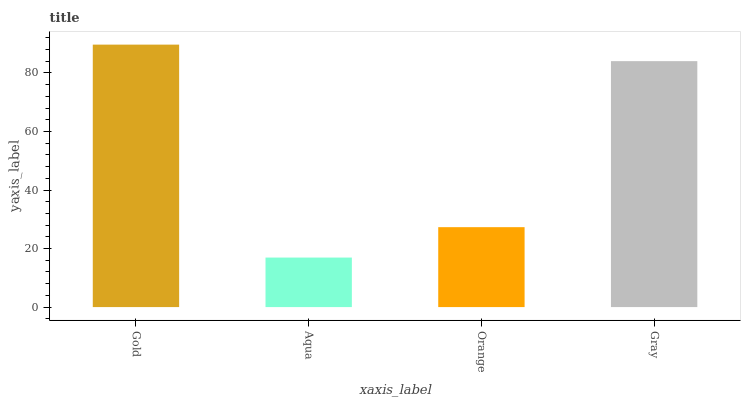Is Aqua the minimum?
Answer yes or no. Yes. Is Gold the maximum?
Answer yes or no. Yes. Is Orange the minimum?
Answer yes or no. No. Is Orange the maximum?
Answer yes or no. No. Is Orange greater than Aqua?
Answer yes or no. Yes. Is Aqua less than Orange?
Answer yes or no. Yes. Is Aqua greater than Orange?
Answer yes or no. No. Is Orange less than Aqua?
Answer yes or no. No. Is Gray the high median?
Answer yes or no. Yes. Is Orange the low median?
Answer yes or no. Yes. Is Orange the high median?
Answer yes or no. No. Is Aqua the low median?
Answer yes or no. No. 